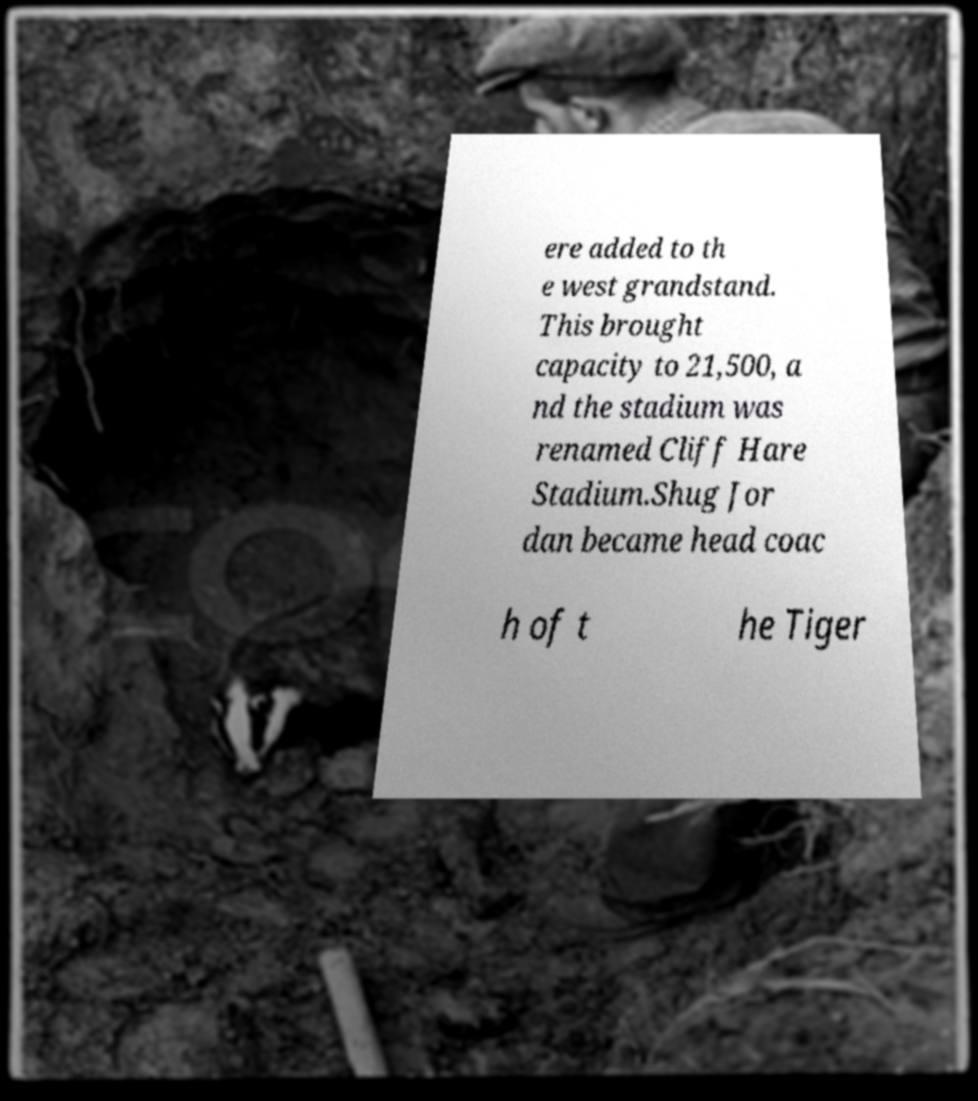Can you accurately transcribe the text from the provided image for me? ere added to th e west grandstand. This brought capacity to 21,500, a nd the stadium was renamed Cliff Hare Stadium.Shug Jor dan became head coac h of t he Tiger 